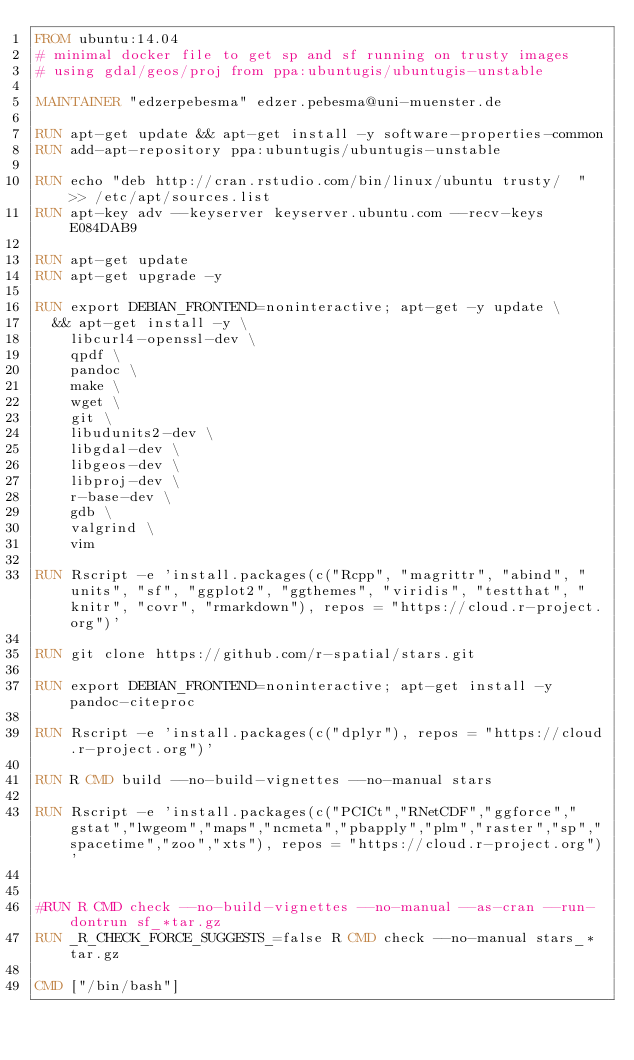Convert code to text. <code><loc_0><loc_0><loc_500><loc_500><_Dockerfile_>FROM ubuntu:14.04
# minimal docker file to get sp and sf running on trusty images
# using gdal/geos/proj from ppa:ubuntugis/ubuntugis-unstable

MAINTAINER "edzerpebesma" edzer.pebesma@uni-muenster.de

RUN apt-get update && apt-get install -y software-properties-common
RUN add-apt-repository ppa:ubuntugis/ubuntugis-unstable

RUN echo "deb http://cran.rstudio.com/bin/linux/ubuntu trusty/  " >> /etc/apt/sources.list
RUN apt-key adv --keyserver keyserver.ubuntu.com --recv-keys E084DAB9

RUN apt-get update
RUN apt-get upgrade -y

RUN export DEBIAN_FRONTEND=noninteractive; apt-get -y update \
  && apt-get install -y \
	libcurl4-openssl-dev \
	qpdf \
	pandoc \
	make \
	wget \
	git \
	libudunits2-dev \
	libgdal-dev \
	libgeos-dev \
	libproj-dev \
	r-base-dev \
	gdb \
	valgrind \
	vim

RUN Rscript -e 'install.packages(c("Rcpp", "magrittr", "abind", "units", "sf", "ggplot2", "ggthemes", "viridis", "testthat", "knitr", "covr", "rmarkdown"), repos = "https://cloud.r-project.org")'

RUN git clone https://github.com/r-spatial/stars.git

RUN export DEBIAN_FRONTEND=noninteractive; apt-get install -y pandoc-citeproc

RUN Rscript -e 'install.packages(c("dplyr"), repos = "https://cloud.r-project.org")'

RUN R CMD build --no-build-vignettes --no-manual stars

RUN Rscript -e 'install.packages(c("PCICt","RNetCDF","ggforce","gstat","lwgeom","maps","ncmeta","pbapply","plm","raster","sp","spacetime","zoo","xts"), repos = "https://cloud.r-project.org")'


#RUN R CMD check --no-build-vignettes --no-manual --as-cran --run-dontrun sf_*tar.gz
RUN _R_CHECK_FORCE_SUGGESTS_=false R CMD check --no-manual stars_*tar.gz

CMD ["/bin/bash"]
</code> 